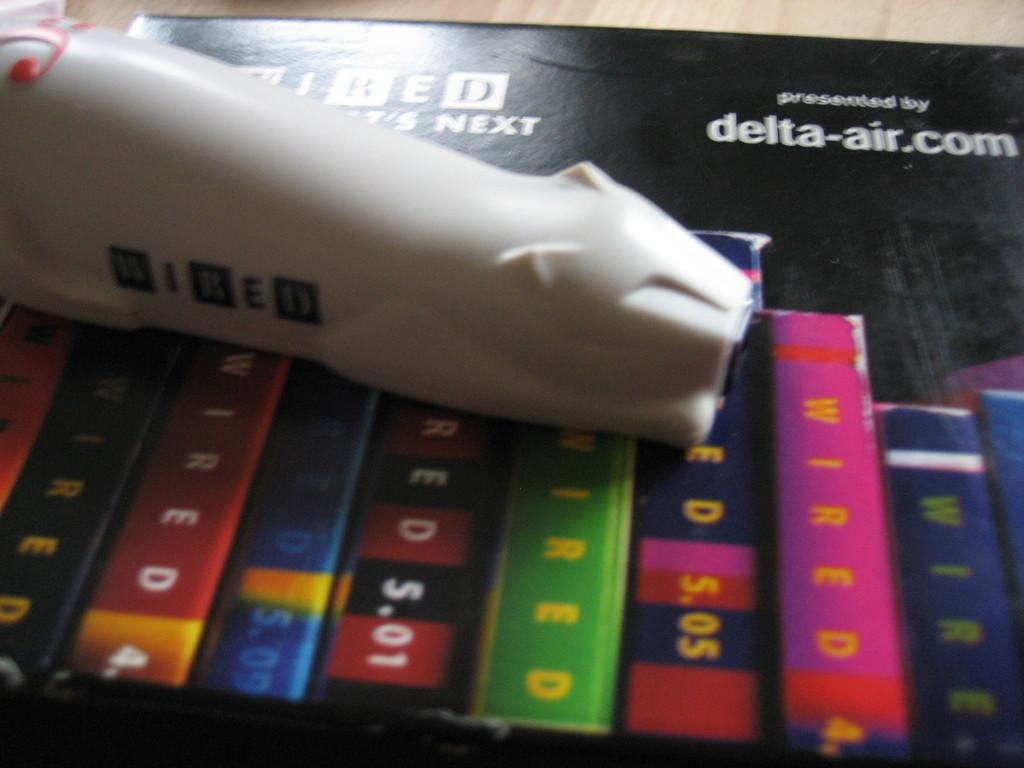<image>
Write a terse but informative summary of the picture. A ceramic cat is sitting upon a box that is presented by delta-air.com. 